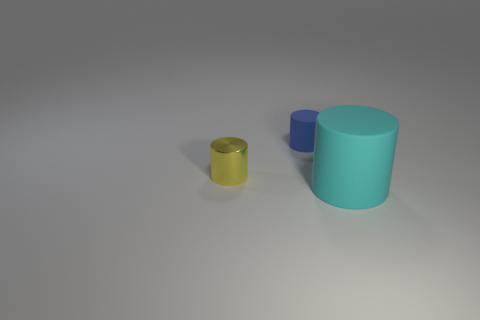What size is the cylinder that is both in front of the tiny blue thing and to the right of the yellow object?
Your answer should be very brief. Large. What number of cyan matte things have the same size as the metallic thing?
Your response must be concise. 0. How many metallic things are either tiny things or yellow cylinders?
Give a very brief answer. 1. What is the material of the object that is to the right of the cylinder behind the small shiny cylinder?
Provide a succinct answer. Rubber. What number of objects are either big matte objects or cylinders behind the big cyan cylinder?
Offer a very short reply. 3. There is a cyan cylinder that is made of the same material as the blue thing; what is its size?
Your answer should be very brief. Large. How many red objects are large things or metal cylinders?
Keep it short and to the point. 0. Is there anything else that has the same material as the tiny yellow cylinder?
Give a very brief answer. No. Is the shape of the tiny object that is right of the yellow shiny thing the same as the small object to the left of the small matte cylinder?
Give a very brief answer. Yes. What number of yellow metal cylinders are there?
Keep it short and to the point. 1. 